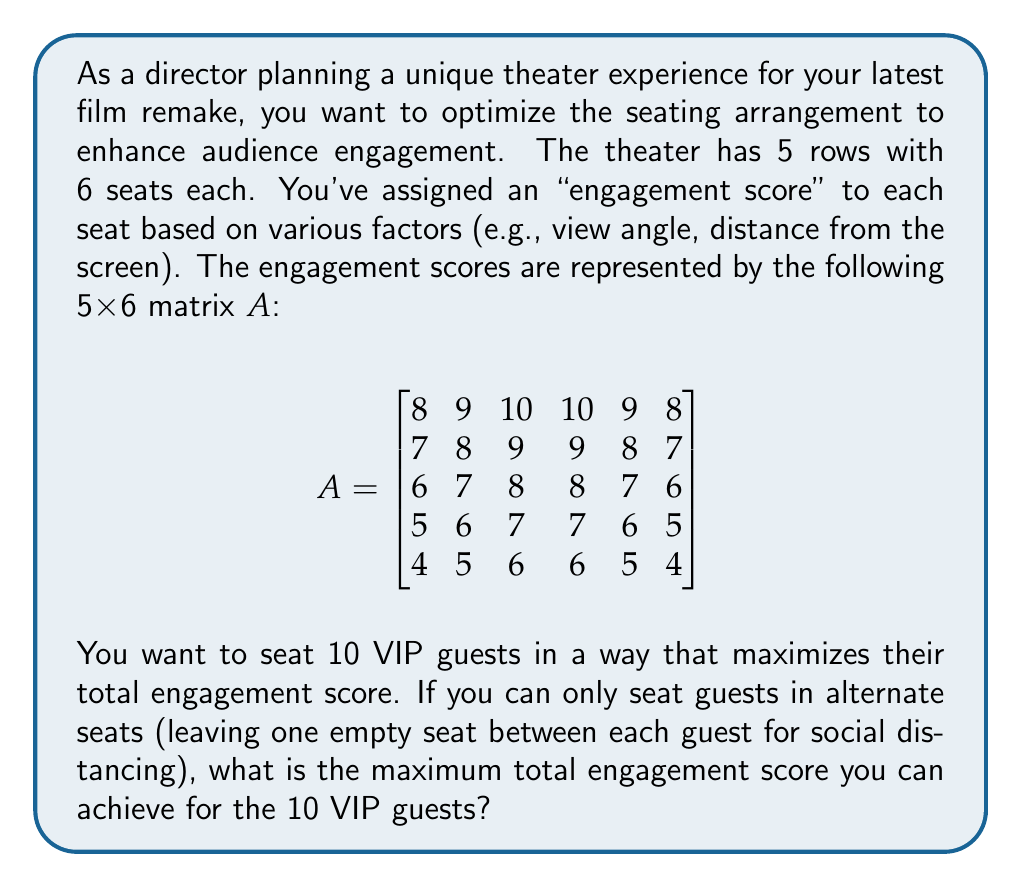Could you help me with this problem? To solve this problem, we'll follow these steps:

1) First, we need to create a matrix B that represents the available seats after applying the social distancing rule. We can do this by setting every other element to 0:

$$ B = \begin{bmatrix}
8 & 0 & 10 & 0 & 9 & 0 \\
0 & 8 & 0 & 9 & 0 & 7 \\
6 & 0 & 8 & 0 & 7 & 0 \\
0 & 6 & 0 & 7 & 0 & 5 \\
4 & 0 & 6 & 0 & 5 & 0
\end{bmatrix} $$

2) Now, we need to find the 10 highest values in this matrix B. We can do this by:
   a) Flattening the matrix into a 1D array
   b) Sorting the array in descending order
   c) Summing the first 10 elements

3) Flattening and sorting B gives us:
   10, 9, 9, 8, 8, 8, 7, 7, 7, 6, 6, 6, 5, 5, 4

4) The sum of the first 10 elements is:
   10 + 9 + 9 + 8 + 8 + 8 + 7 + 7 + 7 + 6 = 79

Therefore, the maximum total engagement score for the 10 VIP guests is 79.
Answer: 79 